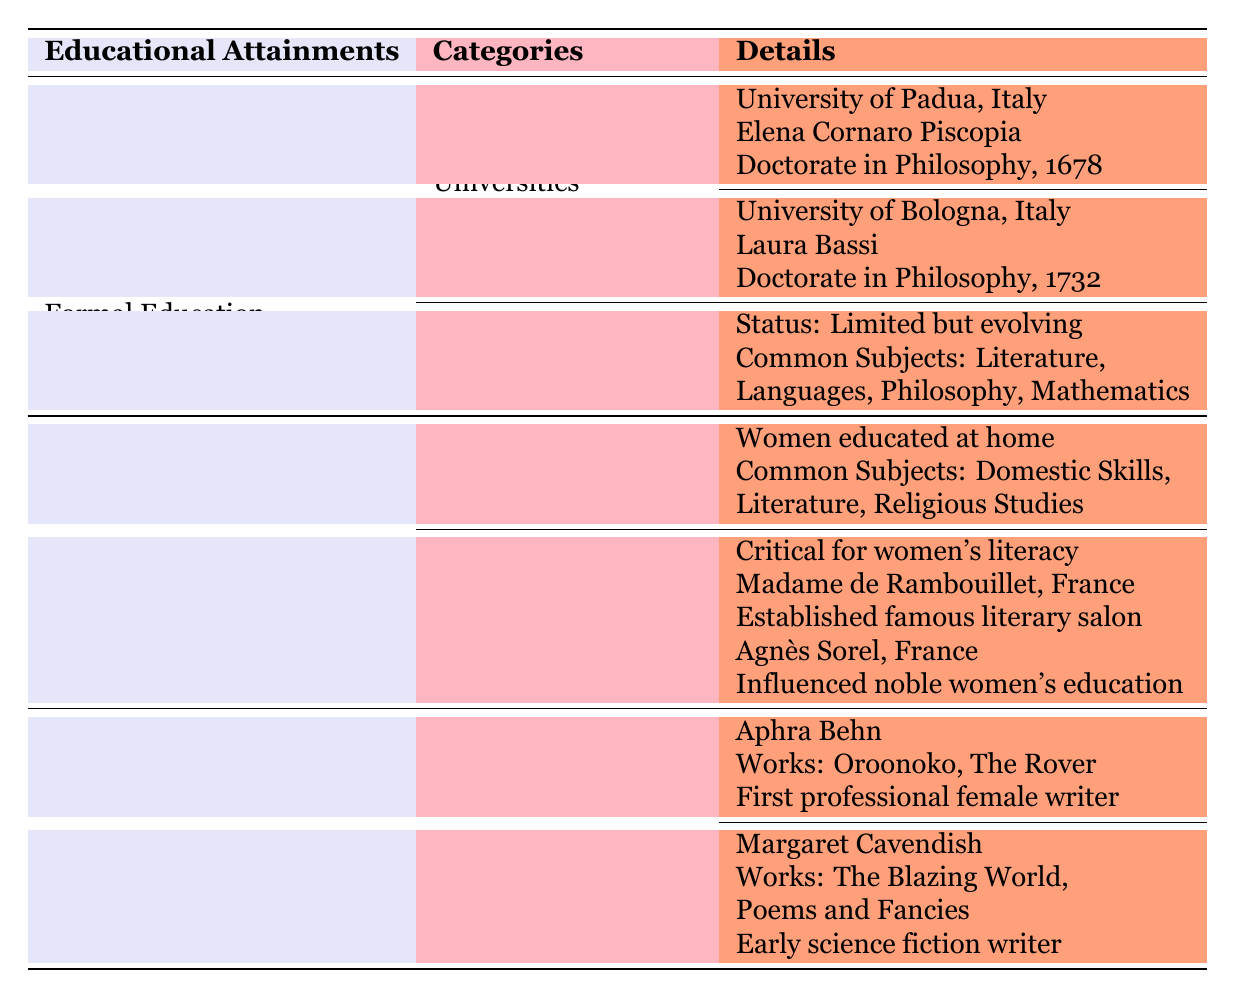What degree did Elena Cornaro Piscopia earn? The table indicates that Elena Cornaro Piscopia earned a Doctorate in Philosophy at the University of Padua.
Answer: Doctorate in Philosophy Which university is associated with Laura Bassi? According to the table, Laura Bassi is associated with the University of Bologna in Italy.
Answer: University of Bologna True or false: Women had access to unlimited education in the 17th century. The table states that educational status for women was "Limited but evolving," indicating that access was not unlimited.
Answer: False How many subjects were commonly taught in household education? The table lists three common subjects in household education: Domestic Skills, Literature, and Religious Studies, totaling three subjects.
Answer: 3 Which literary figure established a famous salon in France? The table mentions Madame de Rambouillet as the figure who established one of the first famous literary salons in France.
Answer: Madame de Rambouillet What is the significance of literary salons for women's education? The table highlights that literary salons were critical in promoting women's literacy and education, suggesting their importance in this context.
Answer: Critical for women's literacy and education Compare the notable works of Aphra Behn and Margaret Cavendish. Aphra Behn's notable works include "Oroonoko" and "The Rover," while Margaret Cavendish is known for "The Blazing World" and "Poems and Fancies." This analysis shows that both authors made significant literary contributions during their time, though their works differ in genre and subject.
Answer: Different works: Behn - Oroonoko, The Rover; Cavendish - The Blazing World, Poems and Fancies What were the common subjects in women's formal education? The table shows that common subjects for women's formal education included Literature, Languages, Philosophy, and Mathematics. This indicates the focus of education provided to women at the time.
Answer: Literature, Languages, Philosophy, Mathematics 